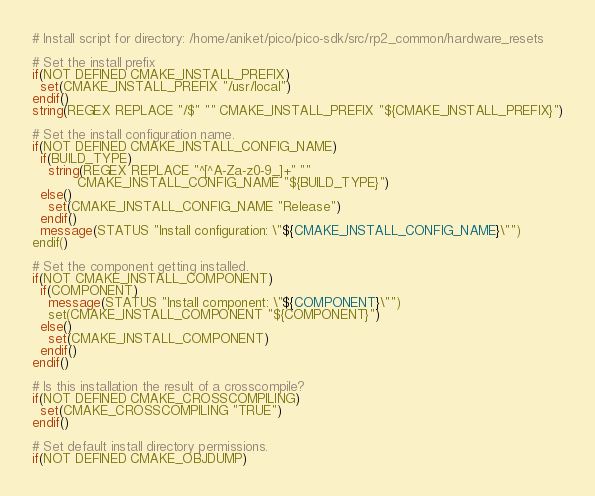Convert code to text. <code><loc_0><loc_0><loc_500><loc_500><_CMake_># Install script for directory: /home/aniket/pico/pico-sdk/src/rp2_common/hardware_resets

# Set the install prefix
if(NOT DEFINED CMAKE_INSTALL_PREFIX)
  set(CMAKE_INSTALL_PREFIX "/usr/local")
endif()
string(REGEX REPLACE "/$" "" CMAKE_INSTALL_PREFIX "${CMAKE_INSTALL_PREFIX}")

# Set the install configuration name.
if(NOT DEFINED CMAKE_INSTALL_CONFIG_NAME)
  if(BUILD_TYPE)
    string(REGEX REPLACE "^[^A-Za-z0-9_]+" ""
           CMAKE_INSTALL_CONFIG_NAME "${BUILD_TYPE}")
  else()
    set(CMAKE_INSTALL_CONFIG_NAME "Release")
  endif()
  message(STATUS "Install configuration: \"${CMAKE_INSTALL_CONFIG_NAME}\"")
endif()

# Set the component getting installed.
if(NOT CMAKE_INSTALL_COMPONENT)
  if(COMPONENT)
    message(STATUS "Install component: \"${COMPONENT}\"")
    set(CMAKE_INSTALL_COMPONENT "${COMPONENT}")
  else()
    set(CMAKE_INSTALL_COMPONENT)
  endif()
endif()

# Is this installation the result of a crosscompile?
if(NOT DEFINED CMAKE_CROSSCOMPILING)
  set(CMAKE_CROSSCOMPILING "TRUE")
endif()

# Set default install directory permissions.
if(NOT DEFINED CMAKE_OBJDUMP)</code> 